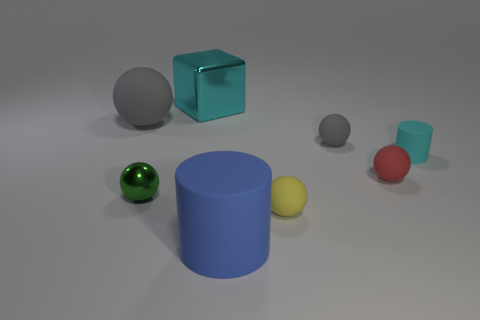There is a cylinder that is in front of the red ball; what material is it?
Offer a terse response. Rubber. Is the tiny red object the same shape as the tiny gray object?
Your answer should be compact. Yes. Is there any other thing that is the same color as the big matte cylinder?
Give a very brief answer. No. The big object that is to the right of the large gray ball and on the left side of the large blue cylinder has what shape?
Provide a succinct answer. Cube. Is the number of large blue rubber cylinders that are behind the small yellow matte sphere the same as the number of cyan blocks behind the cyan matte cylinder?
Give a very brief answer. No. How many blocks are either rubber objects or large blue objects?
Make the answer very short. 0. How many large gray spheres are made of the same material as the small cyan thing?
Offer a terse response. 1. What is the shape of the thing that is the same color as the large rubber ball?
Your answer should be very brief. Sphere. There is a big object that is both on the right side of the large gray rubber object and behind the blue rubber object; what is its material?
Provide a succinct answer. Metal. There is a metal thing that is behind the small green thing; what is its shape?
Give a very brief answer. Cube. 